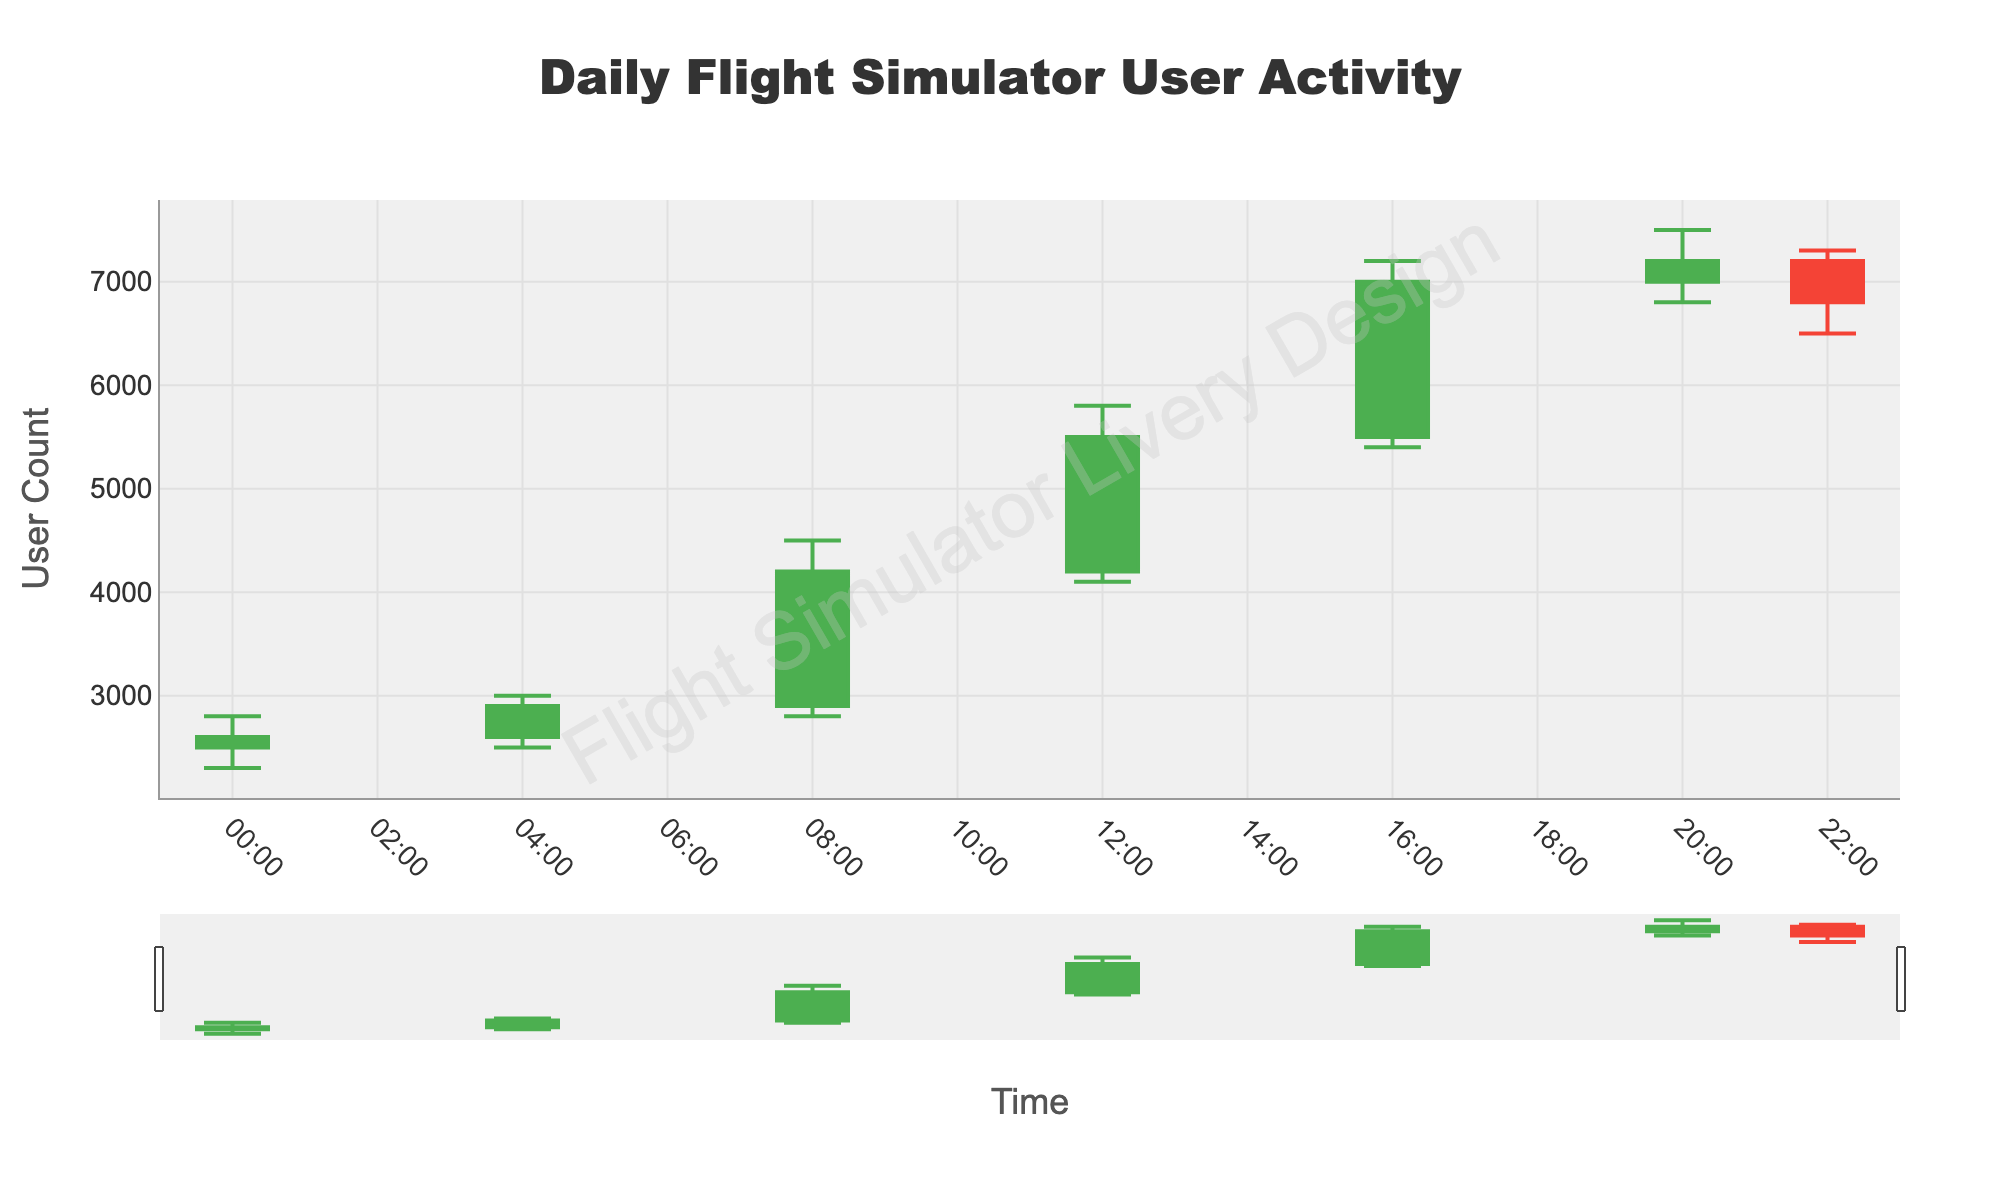What's the title of the chart? The title of the chart is prominently displayed at the top.
Answer: Daily Flight Simulator User Activity What does the x-axis represent? The x-axis represents time, which is formatted in hours and minutes (HH:MM).
Answer: Time What color are the increasing candlesticks? The increasing candlesticks are colored in green.
Answer: Green How many data points are there in the chart? There are seven data points in the chart, each representing a different time segment.
Answer: 7 At what time did the highest user activity occur? The highest user activity is represented by the highest 'High' value in the chart which occurs at 16:00 with a value of 7200.
Answer: 16:00 What is the user count at 08:00 AM's closing? The closing user count at 08:00 is 4200.
Answer: 4200 How much did the user count increase from 08:00 to 12:00? The closing user count at 08:00 was 4200, and it increased to 5500 at 12:00. The difference is 5500 - 4200 = 1300.
Answer: 1300 Which time period saw the greatest range of user counts? The range is calculated as High - Low for each time period. The greatest range is from 12:00 to 16:00 with a range of 7200 - 5400 = 1800.
Answer: 16:00 Was there a decrease in user activity during any time period? If so, when? A decrease in user activity is indicated by a red (decreasing) candlestick. This happens from 20:00 to 22:00 (7200 to 6800).
Answer: Yes, from 20:00 to 22:00 What is the average user count at closing for the entire day? First, sum all closing values: 2600 + 2900 + 4200 + 5500 + 7000 + 7200 + 6800 = 36200. Then divide by the number of periods: 36200 / 7 ≈ 5171.
Answer: 5171 